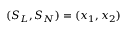<formula> <loc_0><loc_0><loc_500><loc_500>( S _ { L } , S _ { N } ) = ( x _ { 1 } , x _ { 2 } )</formula> 